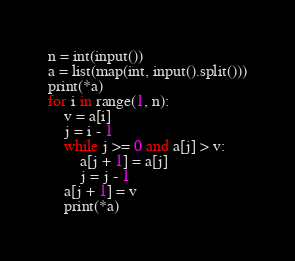Convert code to text. <code><loc_0><loc_0><loc_500><loc_500><_Python_>n = int(input())
a = list(map(int, input().split()))
print(*a)
for i in range(1, n):
    v = a[i]
    j = i - 1
    while j >= 0 and a[j] > v:
        a[j + 1] = a[j]
        j = j - 1
    a[j + 1] = v
    print(*a)
</code> 